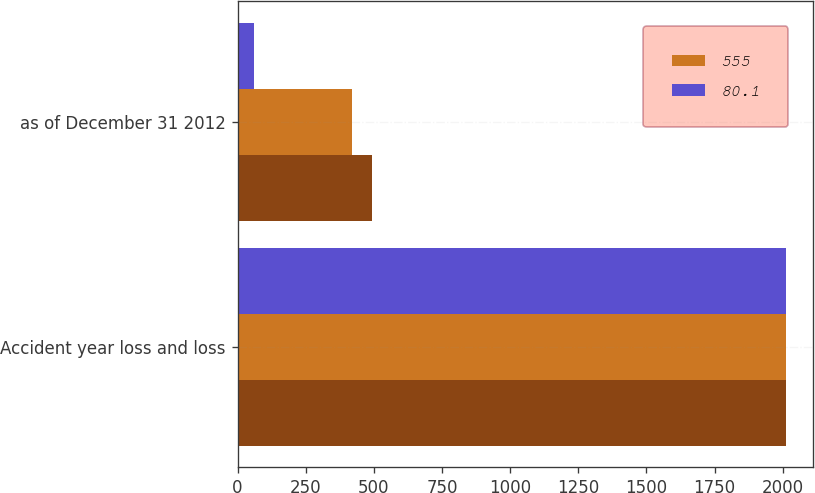Convert chart to OTSL. <chart><loc_0><loc_0><loc_500><loc_500><stacked_bar_chart><ecel><fcel>Accident year loss and loss<fcel>as of December 31 2012<nl><fcel>nan<fcel>2012<fcel>492<nl><fcel>555<fcel>2010<fcel>419<nl><fcel>80.1<fcel>2010<fcel>60.4<nl></chart> 